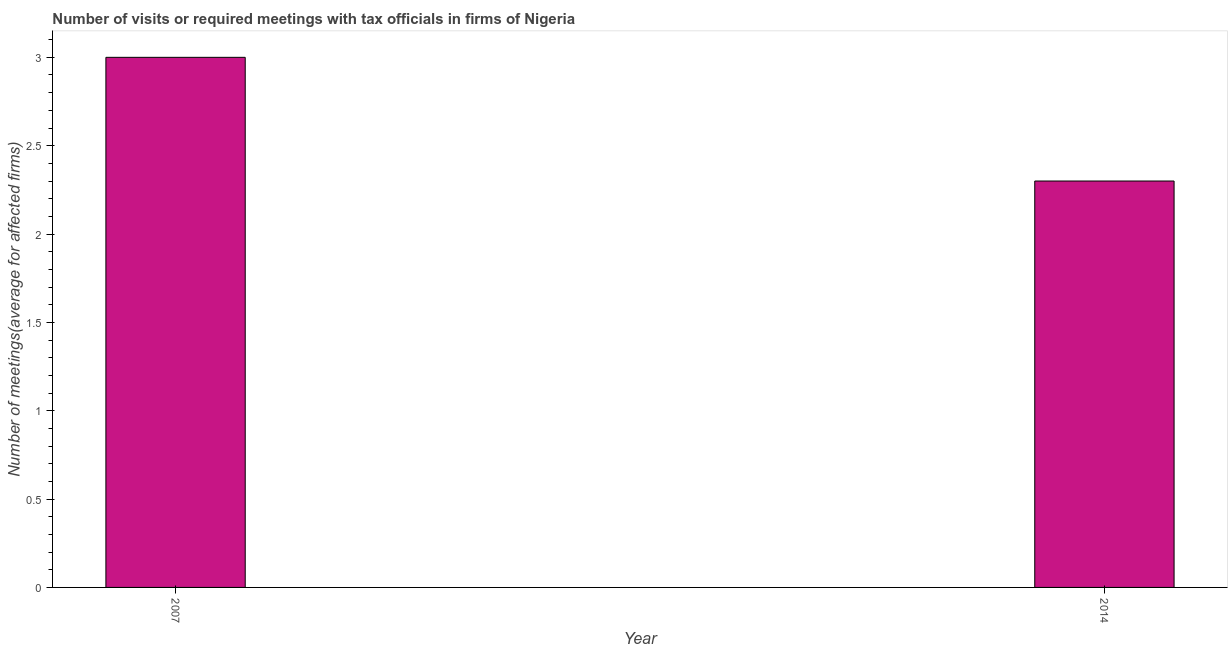Does the graph contain grids?
Ensure brevity in your answer.  No. What is the title of the graph?
Your answer should be very brief. Number of visits or required meetings with tax officials in firms of Nigeria. What is the label or title of the X-axis?
Your response must be concise. Year. What is the label or title of the Y-axis?
Ensure brevity in your answer.  Number of meetings(average for affected firms). Across all years, what is the maximum number of required meetings with tax officials?
Provide a succinct answer. 3. Across all years, what is the minimum number of required meetings with tax officials?
Your response must be concise. 2.3. What is the average number of required meetings with tax officials per year?
Ensure brevity in your answer.  2.65. What is the median number of required meetings with tax officials?
Make the answer very short. 2.65. What is the ratio of the number of required meetings with tax officials in 2007 to that in 2014?
Ensure brevity in your answer.  1.3. Is the number of required meetings with tax officials in 2007 less than that in 2014?
Your answer should be compact. No. In how many years, is the number of required meetings with tax officials greater than the average number of required meetings with tax officials taken over all years?
Offer a terse response. 1. Are the values on the major ticks of Y-axis written in scientific E-notation?
Your answer should be compact. No. What is the Number of meetings(average for affected firms) in 2007?
Provide a short and direct response. 3. What is the difference between the Number of meetings(average for affected firms) in 2007 and 2014?
Ensure brevity in your answer.  0.7. What is the ratio of the Number of meetings(average for affected firms) in 2007 to that in 2014?
Your response must be concise. 1.3. 